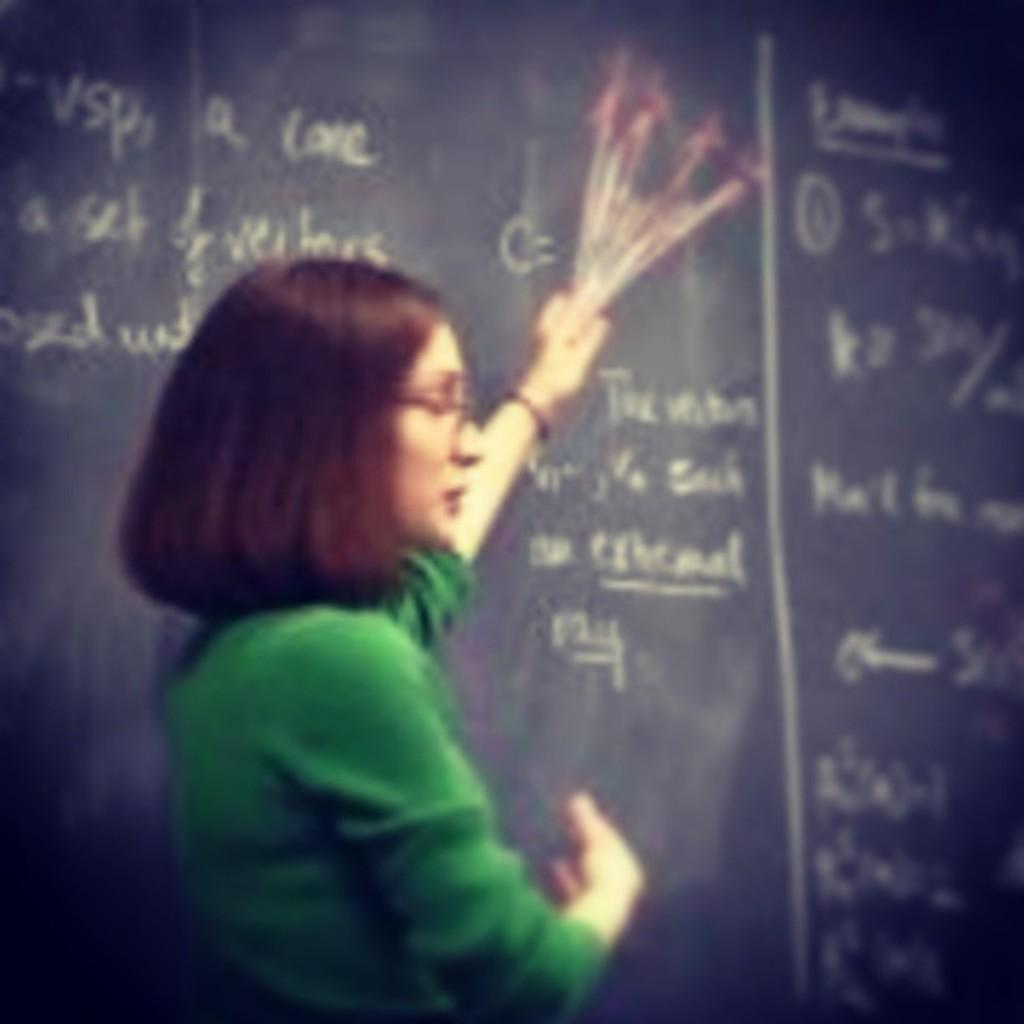Who is present in the image? There is a woman in the image. What is the woman wearing? The woman is wearing a green top. What can be seen in the background of the image? There is a board in the background of the image. What is written or displayed on the board? There is text on the board. What is the woman's temper like in the image? There is no information about the woman's temper in the image. Can you describe the shock factor of the image? The image does not depict any shocking or surprising elements. 